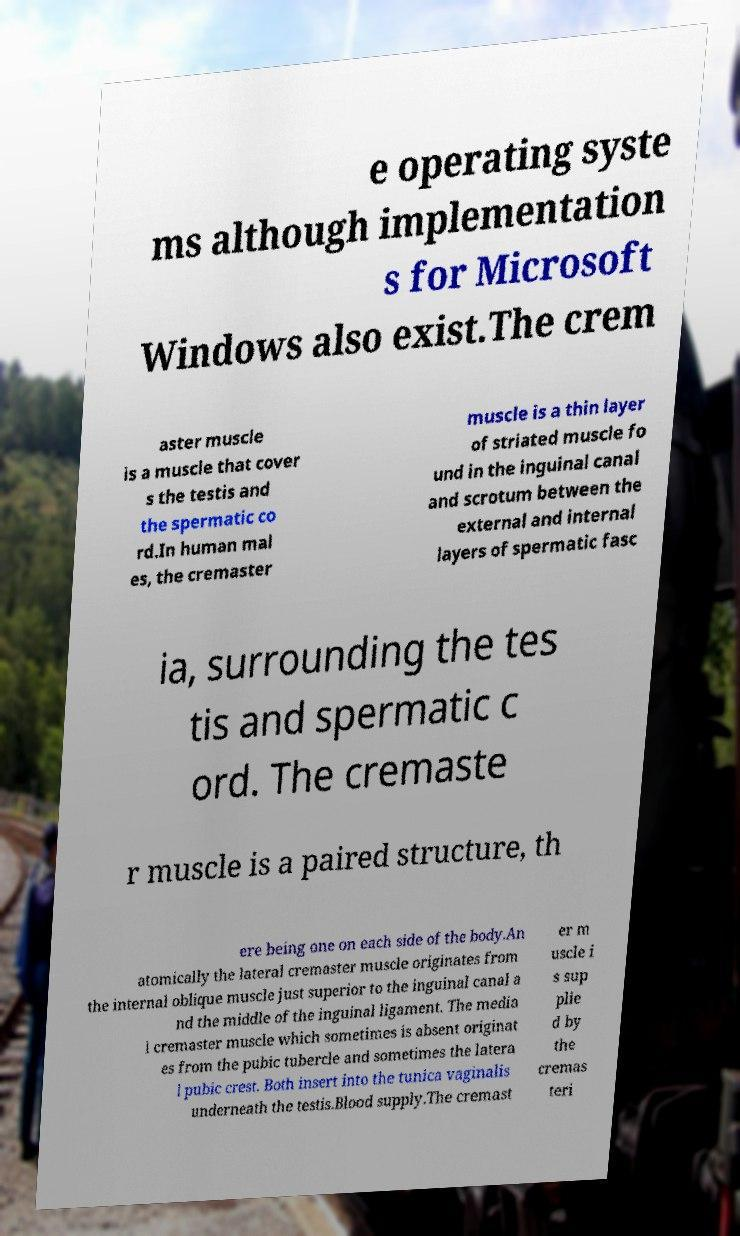Could you assist in decoding the text presented in this image and type it out clearly? e operating syste ms although implementation s for Microsoft Windows also exist.The crem aster muscle is a muscle that cover s the testis and the spermatic co rd.In human mal es, the cremaster muscle is a thin layer of striated muscle fo und in the inguinal canal and scrotum between the external and internal layers of spermatic fasc ia, surrounding the tes tis and spermatic c ord. The cremaste r muscle is a paired structure, th ere being one on each side of the body.An atomically the lateral cremaster muscle originates from the internal oblique muscle just superior to the inguinal canal a nd the middle of the inguinal ligament. The media l cremaster muscle which sometimes is absent originat es from the pubic tubercle and sometimes the latera l pubic crest. Both insert into the tunica vaginalis underneath the testis.Blood supply.The cremast er m uscle i s sup plie d by the cremas teri 